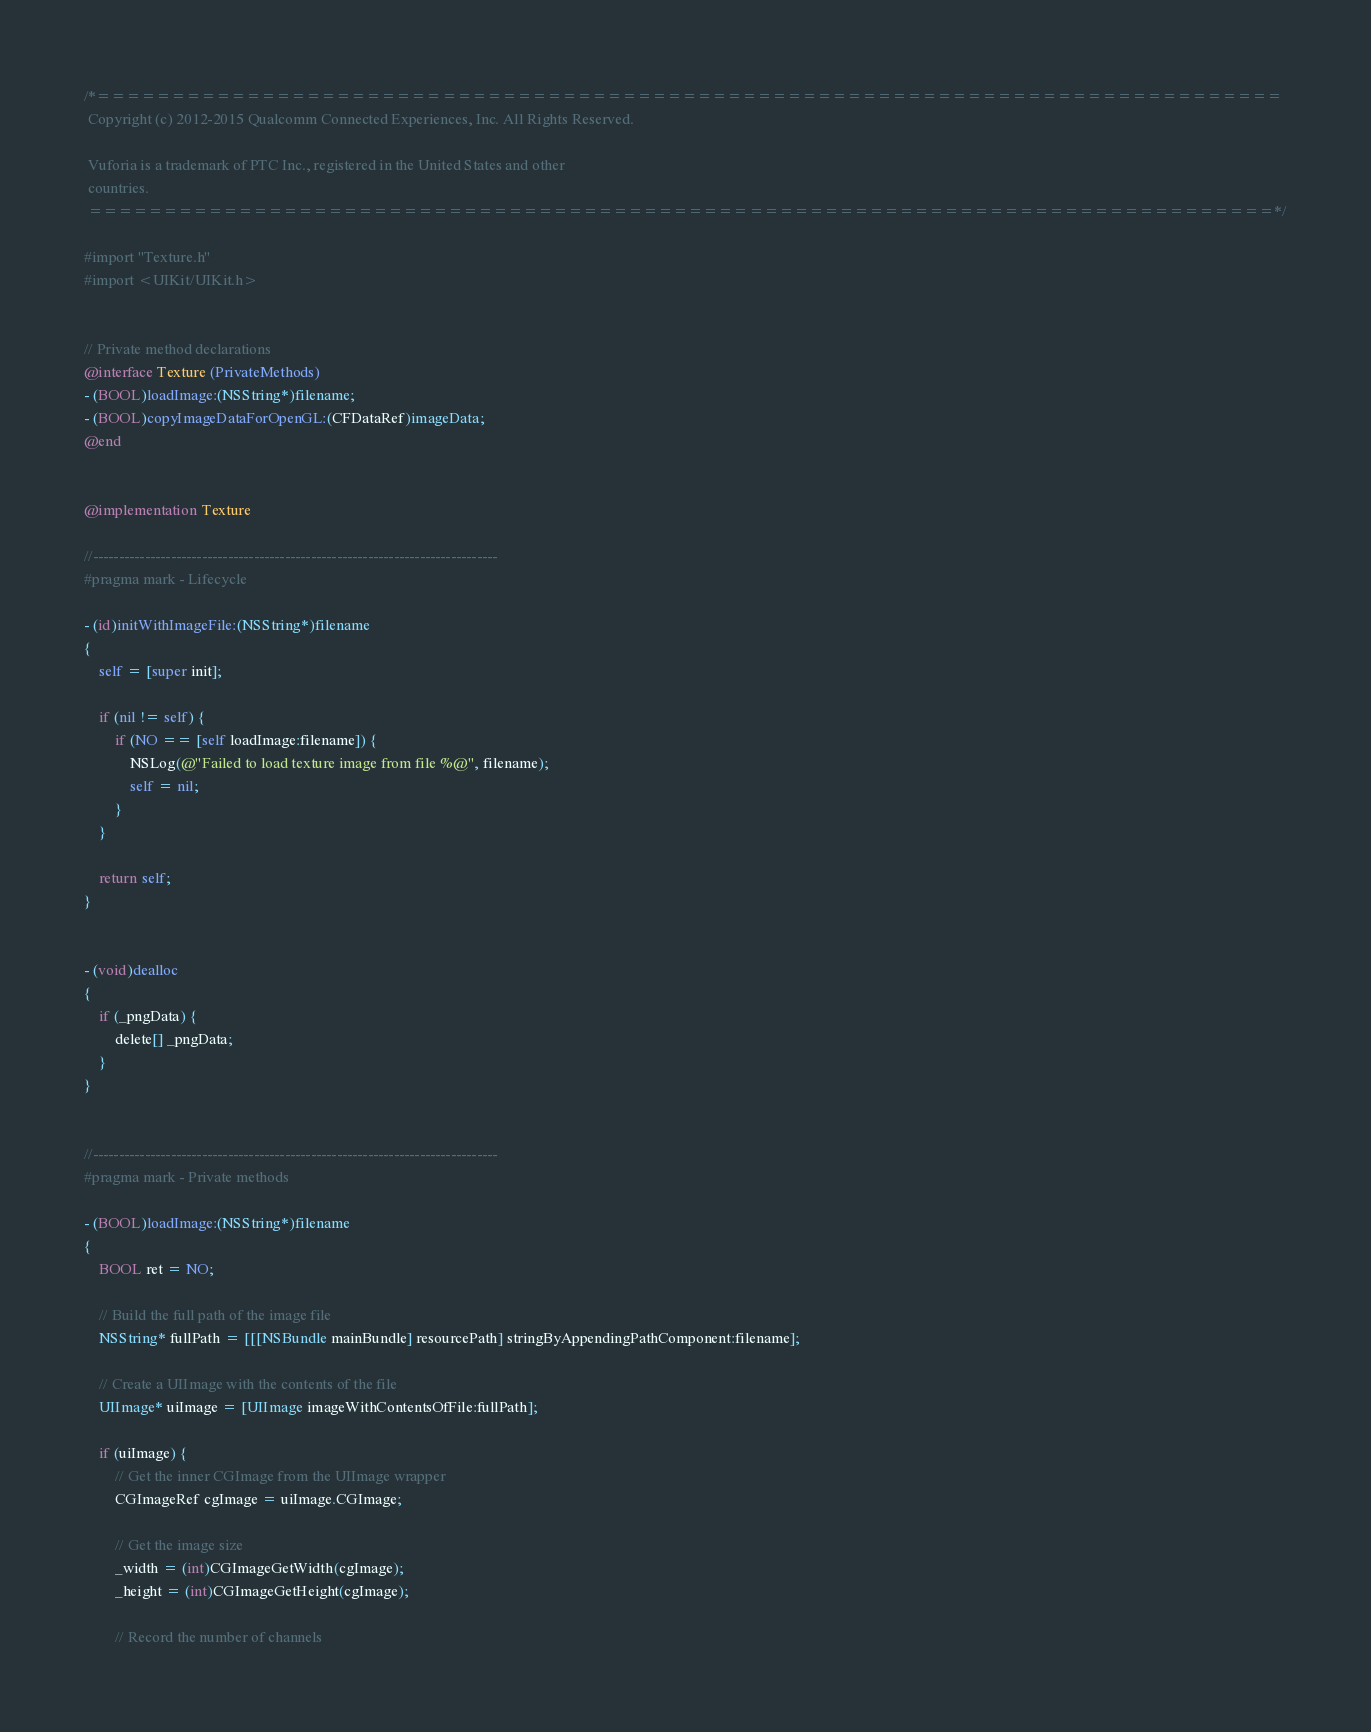<code> <loc_0><loc_0><loc_500><loc_500><_ObjectiveC_>/*===============================================================================
 Copyright (c) 2012-2015 Qualcomm Connected Experiences, Inc. All Rights Reserved.
 
 Vuforia is a trademark of PTC Inc., registered in the United States and other
 countries.
 ===============================================================================*/

#import "Texture.h"
#import <UIKit/UIKit.h>


// Private method declarations
@interface Texture (PrivateMethods)
- (BOOL)loadImage:(NSString*)filename;
- (BOOL)copyImageDataForOpenGL:(CFDataRef)imageData;
@end


@implementation Texture

//------------------------------------------------------------------------------
#pragma mark - Lifecycle

- (id)initWithImageFile:(NSString*)filename
{
    self = [super init];
    
    if (nil != self) {
        if (NO == [self loadImage:filename]) {
            NSLog(@"Failed to load texture image from file %@", filename);
            self = nil;
        }
    }
    
    return self;
}


- (void)dealloc
{
    if (_pngData) {
        delete[] _pngData;
    }
}


//------------------------------------------------------------------------------
#pragma mark - Private methods

- (BOOL)loadImage:(NSString*)filename
{
    BOOL ret = NO;
    
    // Build the full path of the image file
    NSString* fullPath = [[[NSBundle mainBundle] resourcePath] stringByAppendingPathComponent:filename];
    
    // Create a UIImage with the contents of the file
    UIImage* uiImage = [UIImage imageWithContentsOfFile:fullPath];
    
    if (uiImage) {
        // Get the inner CGImage from the UIImage wrapper
        CGImageRef cgImage = uiImage.CGImage;
        
        // Get the image size
        _width = (int)CGImageGetWidth(cgImage);
        _height = (int)CGImageGetHeight(cgImage);
        
        // Record the number of channels</code> 